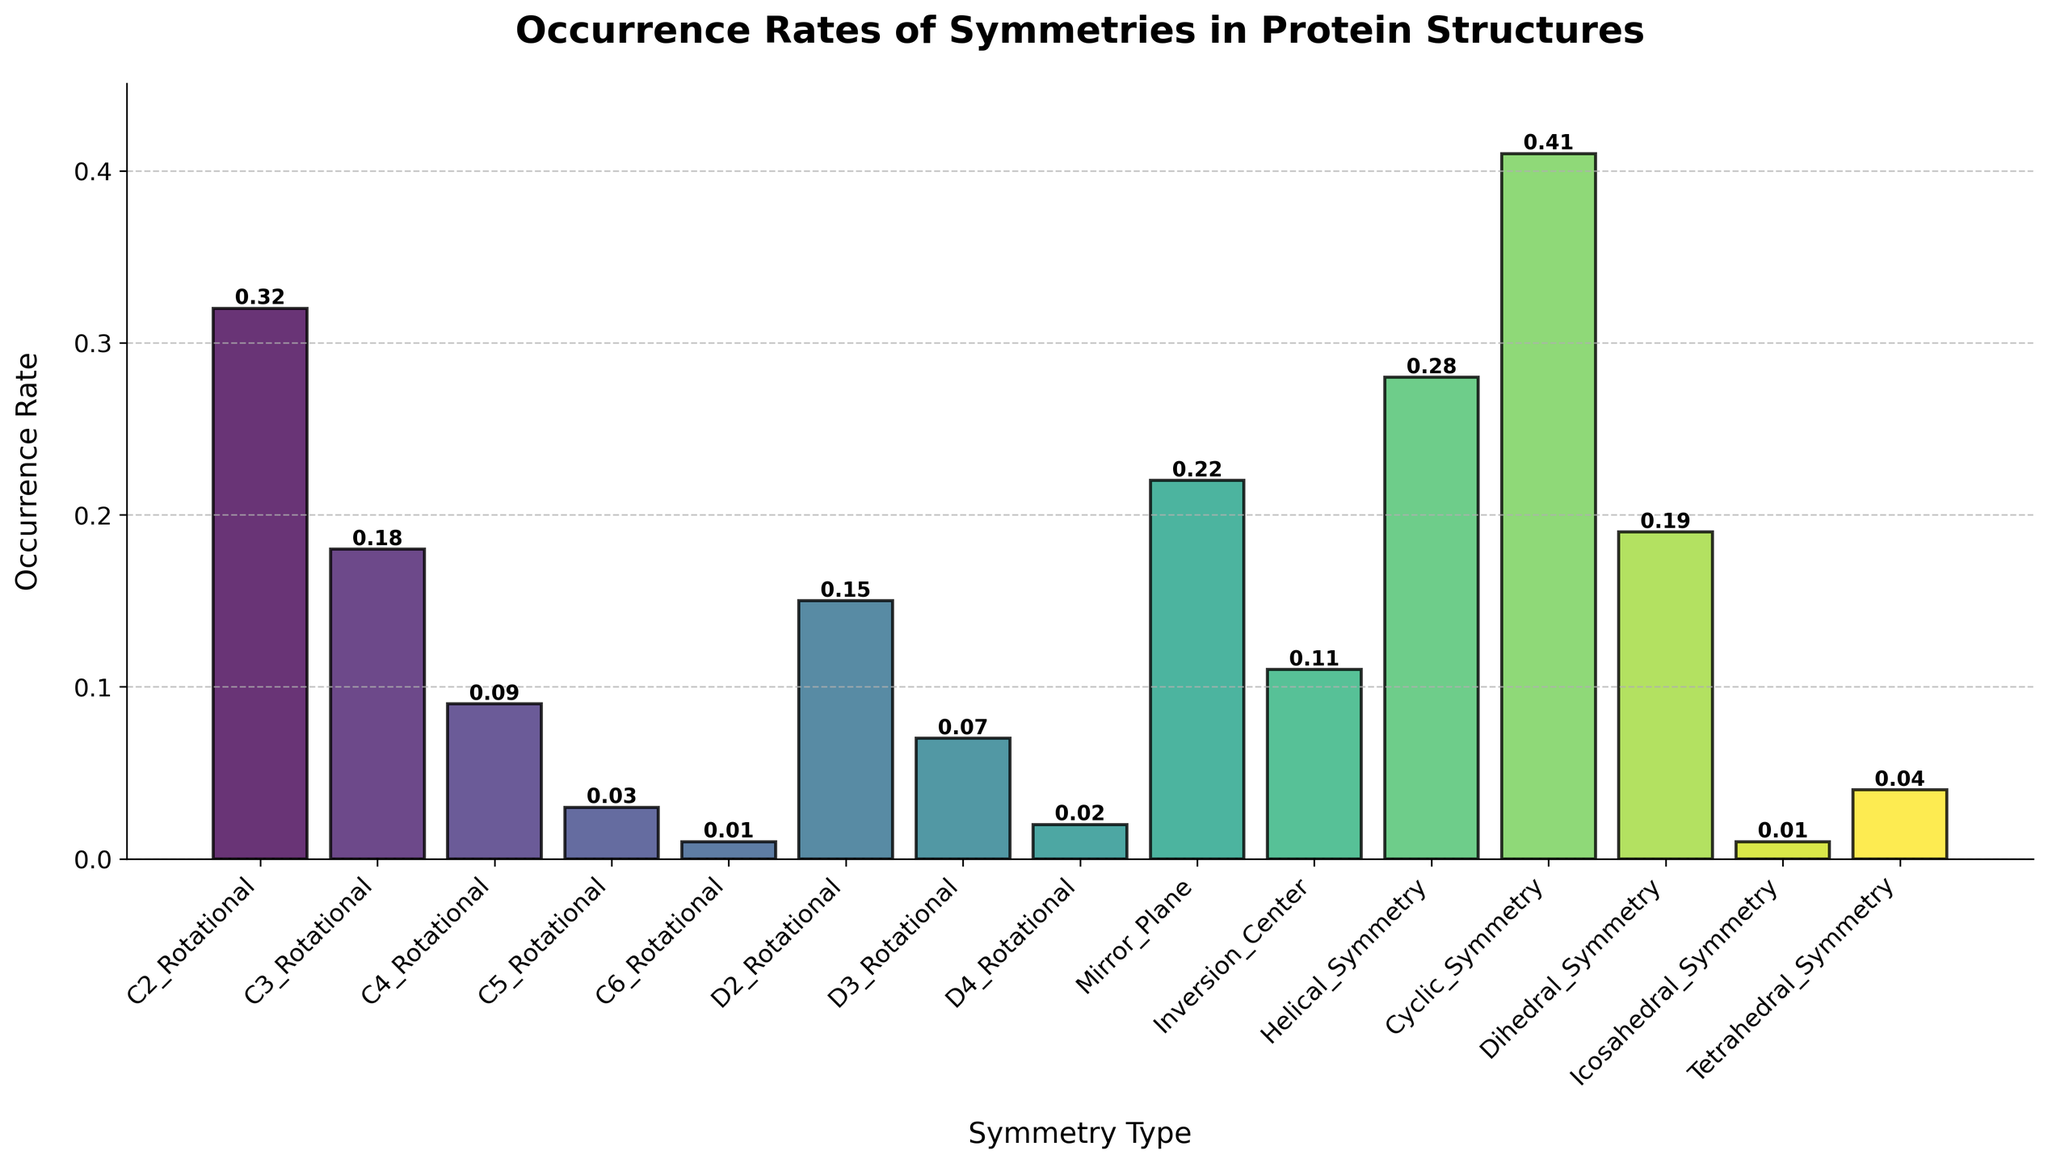What's the most common symmetry type among the protein structures? The symmetry type with the highest bar represents the most common symmetry. According to the plot, Cyclic_Symmetry has the highest occurrence rate at 0.41.
Answer: Cyclic_Symmetry What is the least common symmetry type observed? The shortest bar indicates the least common symmetry type. Icosahedral_Symmetry and C6_Rotational both have the lowest occurrence rate of 0.01.
Answer: Icosahedral_Symmetry and C6_Rotational What's the difference in occurrence rate between Mirror_Plane and Inversion_Center? Mirror_Plane has an occurrence rate of 0.22, while Inversion_Center has 0.11. Subtracting the smaller rate from the larger: 0.22 - 0.11 = 0.11.
Answer: 0.11 Which symmetry type has an occurrence rate closest to the average rate across all types? First, calculate the average occurrence rate by summing all rates and dividing by the number of types. Next, compare the rates to the average to find the closest one. The average rate is (total sum of occurrence rates) / 14 = 0.16. The closest rate is that of C3_Rotational at 0.18.
Answer: C3_Rotational Are there more rotational or non-rotational symmetries, and by how much? Sum the occurrence rates for rotational symmetries (C2_Rotational, C3_Rotational, C4_Rotational, C5_Rotational, C6_Rotational, D2_Rotational, D3_Rotational, D4_Rotational) and non-rotational ones (Mirror_Plane, Inversion_Center, Helical_Symmetry, Cyclic_Symmetry, Dihedral_Symmetry, Icosahedral_Symmetry, Tetrahedral_Symmetry). Rotational = 0.85, Non-rotational = 1.28. Non-rotational symmetries are more by 1.28 - 0.85 = 0.43.
Answer: Non-rotational, by 0.43 What proportion of the symmetry types have an occurrence rate greater than 0.2? Identify the bars exceeding the 0.2 mark. These are C2_Rotational, Mirror_Plane, Helical_Symmetry, and Cyclic_Symmetry, totaling 4 out of 14 types. Proportion = 4 / 14 = 0.2857.
Answer: 0.29 How does the occurrence rate of Helical_Symmetry compare to Dihedral_Symmetry? Compare the heights of the two bars. Helical_Symmetry has an occurrence rate of 0.28, and Dihedral_Symmetry is 0.19. Helical_Symmetry is greater by 0.28 - 0.19 = 0.09.
Answer: Helical_Symmetry is greater by 0.09 What's the total occurrence rate of all rotational symmetries combined? Sum the occurrence rates of all rotational symmetry types: 0.32 + 0.18 + 0.09 + 0.03 + 0.01 + 0.15 + 0.07 + 0.02 = 0.87.
Answer: 0.87 Which symmetry types have an occurrence rate between 0.1 and 0.2? Identify the bars within the given range. These are C3_Rotational, D2_Rotational, Inversion_Center, and Dihedral_Symmetry.
Answer: C3_Rotational, D2_Rotational, Inversion_Center, Dihedral_Symmetry 